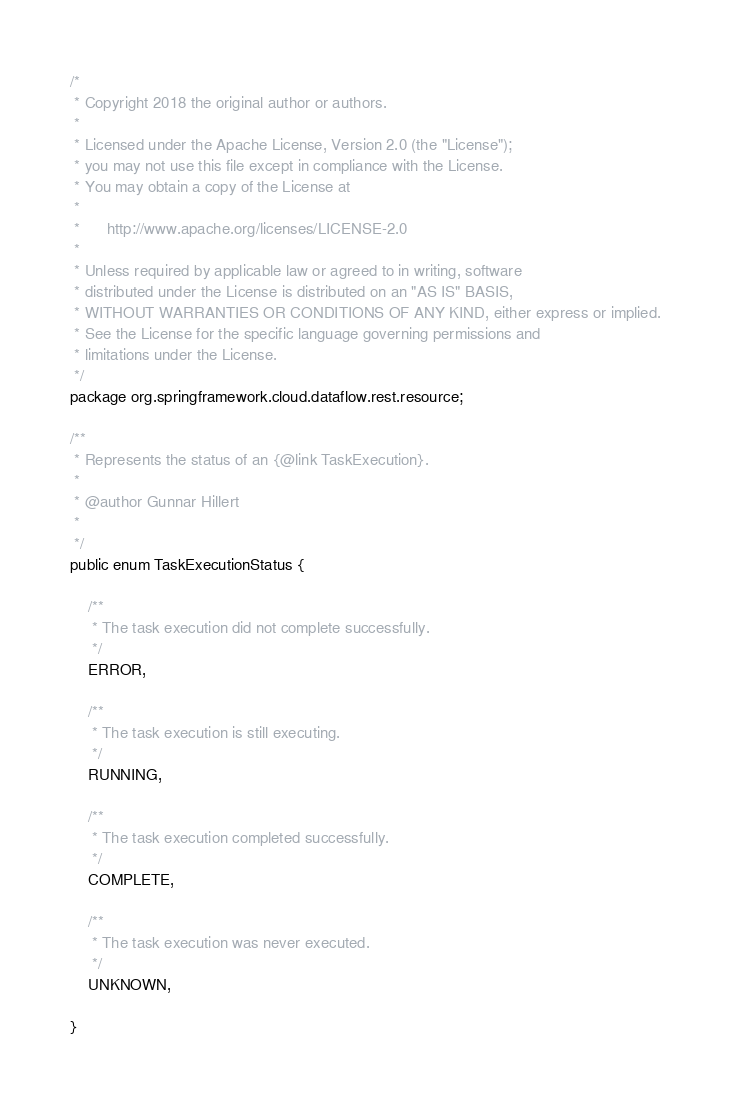Convert code to text. <code><loc_0><loc_0><loc_500><loc_500><_Java_>/*
 * Copyright 2018 the original author or authors.
 *
 * Licensed under the Apache License, Version 2.0 (the "License");
 * you may not use this file except in compliance with the License.
 * You may obtain a copy of the License at
 *
 *      http://www.apache.org/licenses/LICENSE-2.0
 *
 * Unless required by applicable law or agreed to in writing, software
 * distributed under the License is distributed on an "AS IS" BASIS,
 * WITHOUT WARRANTIES OR CONDITIONS OF ANY KIND, either express or implied.
 * See the License for the specific language governing permissions and
 * limitations under the License.
 */
package org.springframework.cloud.dataflow.rest.resource;

/**
 * Represents the status of an {@link TaskExecution}.
 *
 * @author Gunnar Hillert
 *
 */
public enum TaskExecutionStatus {

	/**
	 * The task execution did not complete successfully.
	 */
	ERROR,

	/**
	 * The task execution is still executing.
	 */
	RUNNING,

	/**
	 * The task execution completed successfully.
	 */
	COMPLETE,

	/**
	 * The task execution was never executed.
	 */
	UNKNOWN,

}
</code> 